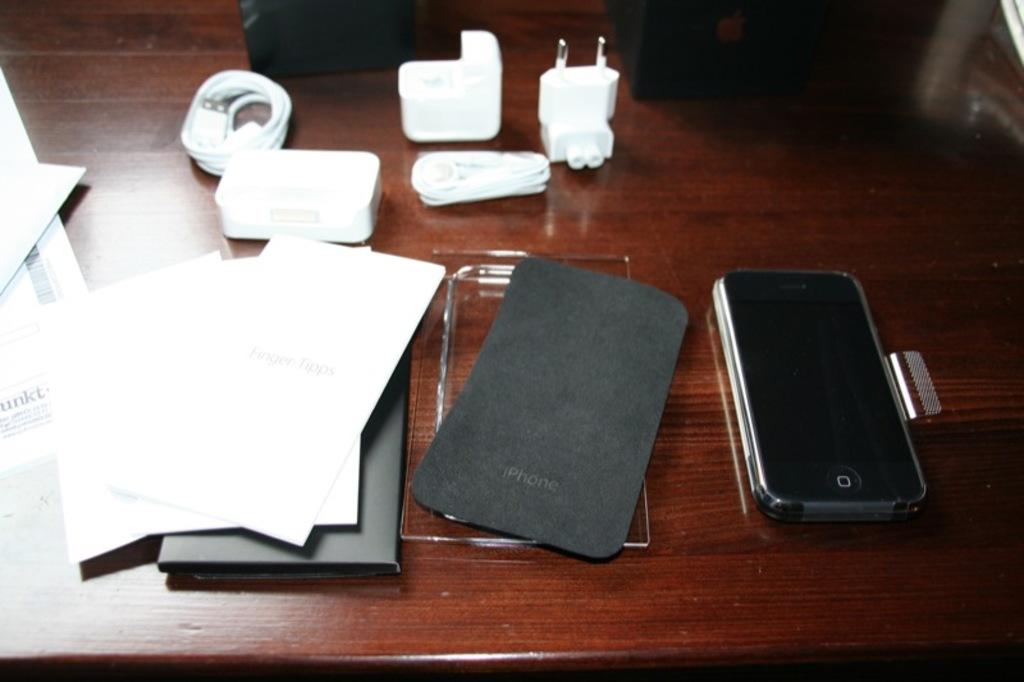What phone brand is on the back cover at the bottom?
Give a very brief answer. Iphone. 